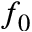Convert formula to latex. <formula><loc_0><loc_0><loc_500><loc_500>f _ { 0 }</formula> 